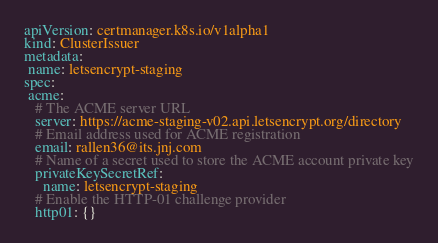<code> <loc_0><loc_0><loc_500><loc_500><_YAML_>apiVersion: certmanager.k8s.io/v1alpha1
kind: ClusterIssuer
metadata:
 name: letsencrypt-staging
spec:
 acme:
   # The ACME server URL
   server: https://acme-staging-v02.api.letsencrypt.org/directory
   # Email address used for ACME registration
   email: rallen36@its.jnj.com
   # Name of a secret used to store the ACME account private key
   privateKeySecretRef:
     name: letsencrypt-staging
   # Enable the HTTP-01 challenge provider
   http01: {}
</code> 